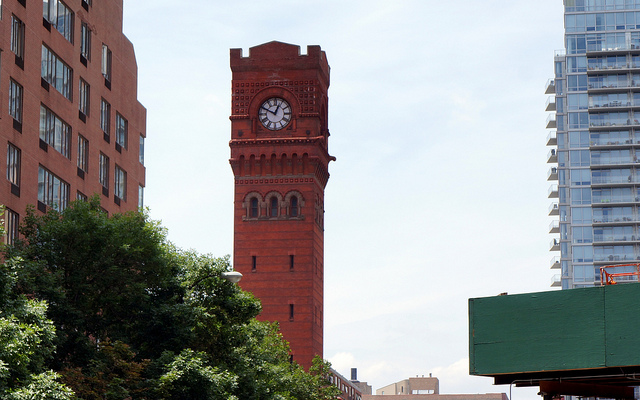Is this clock tower functional? Considering the well-maintained condition of the clock and tower, it seems plausible that it is still operational. 